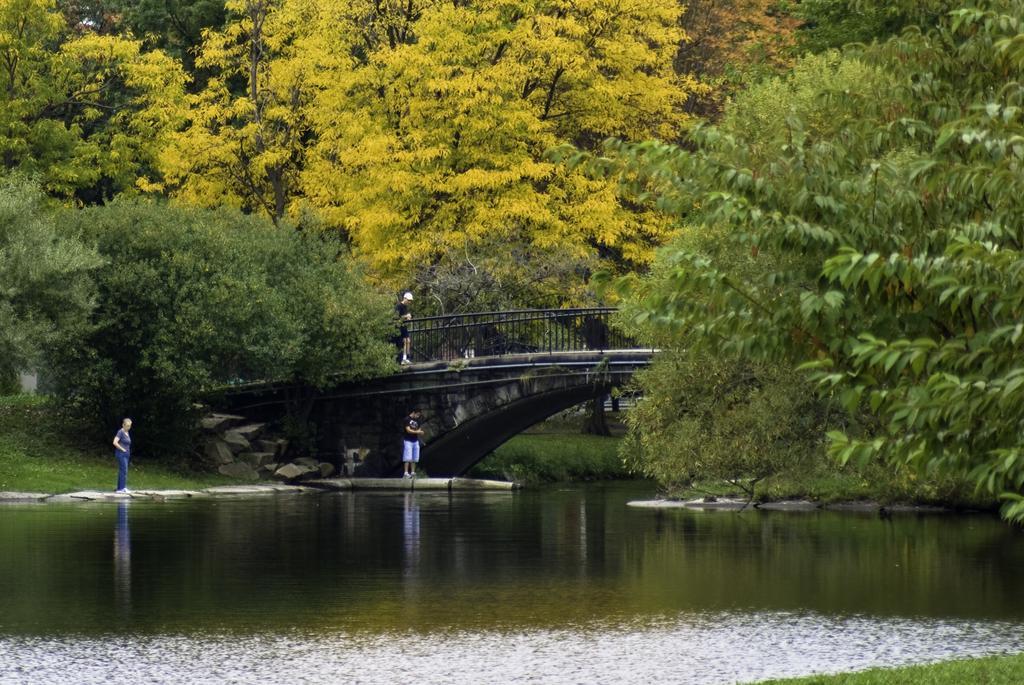In one or two sentences, can you explain what this image depicts? In this image, we can see a bridge and there is water, we can see a person standing, there are some trees. 